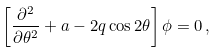<formula> <loc_0><loc_0><loc_500><loc_500>\left [ \frac { \partial ^ { 2 } } { \partial \theta ^ { 2 } } + a - 2 q \cos 2 \theta \right ] \phi = 0 \, ,</formula> 